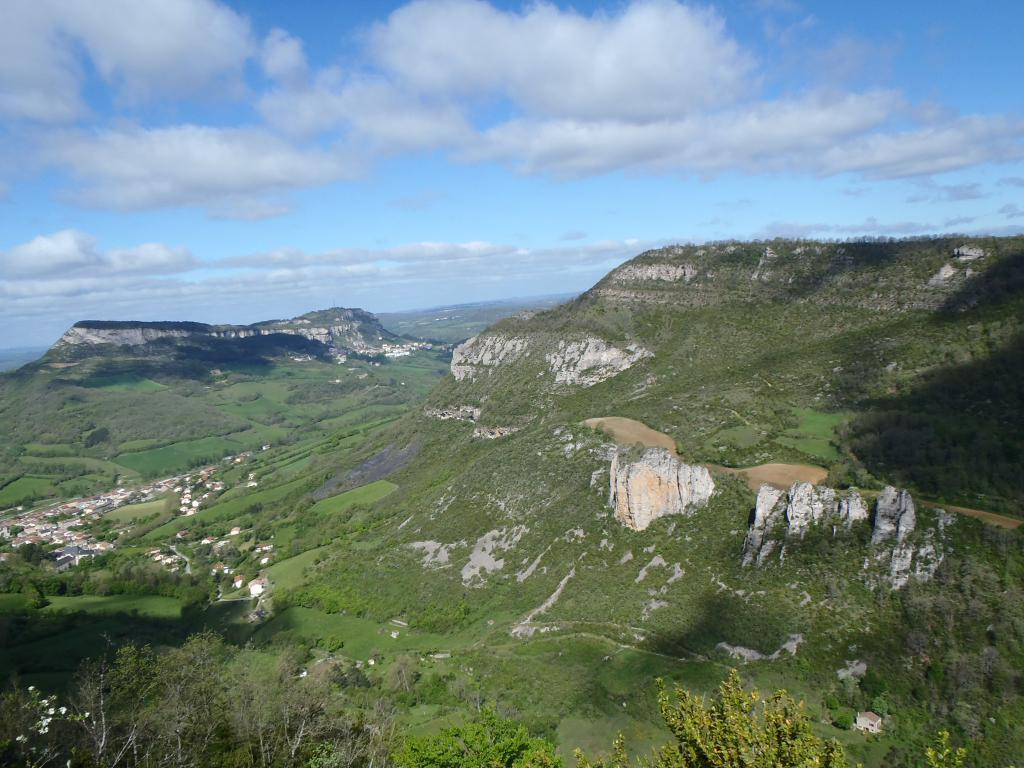What type of natural formation can be seen in the image? There are mountains in the image. What is covering the mountains? There is grass on the mountains. What other type of vegetation is present in the image? There are trees in the image. What is visible above the mountains and trees? The sky is visible in the image. How would you describe the color of the sky in the image? The sky has a white and blue color. How many toes can be seen on the goose in the image? There is no goose present in the image, so it is not possible to determine the number of toes. 